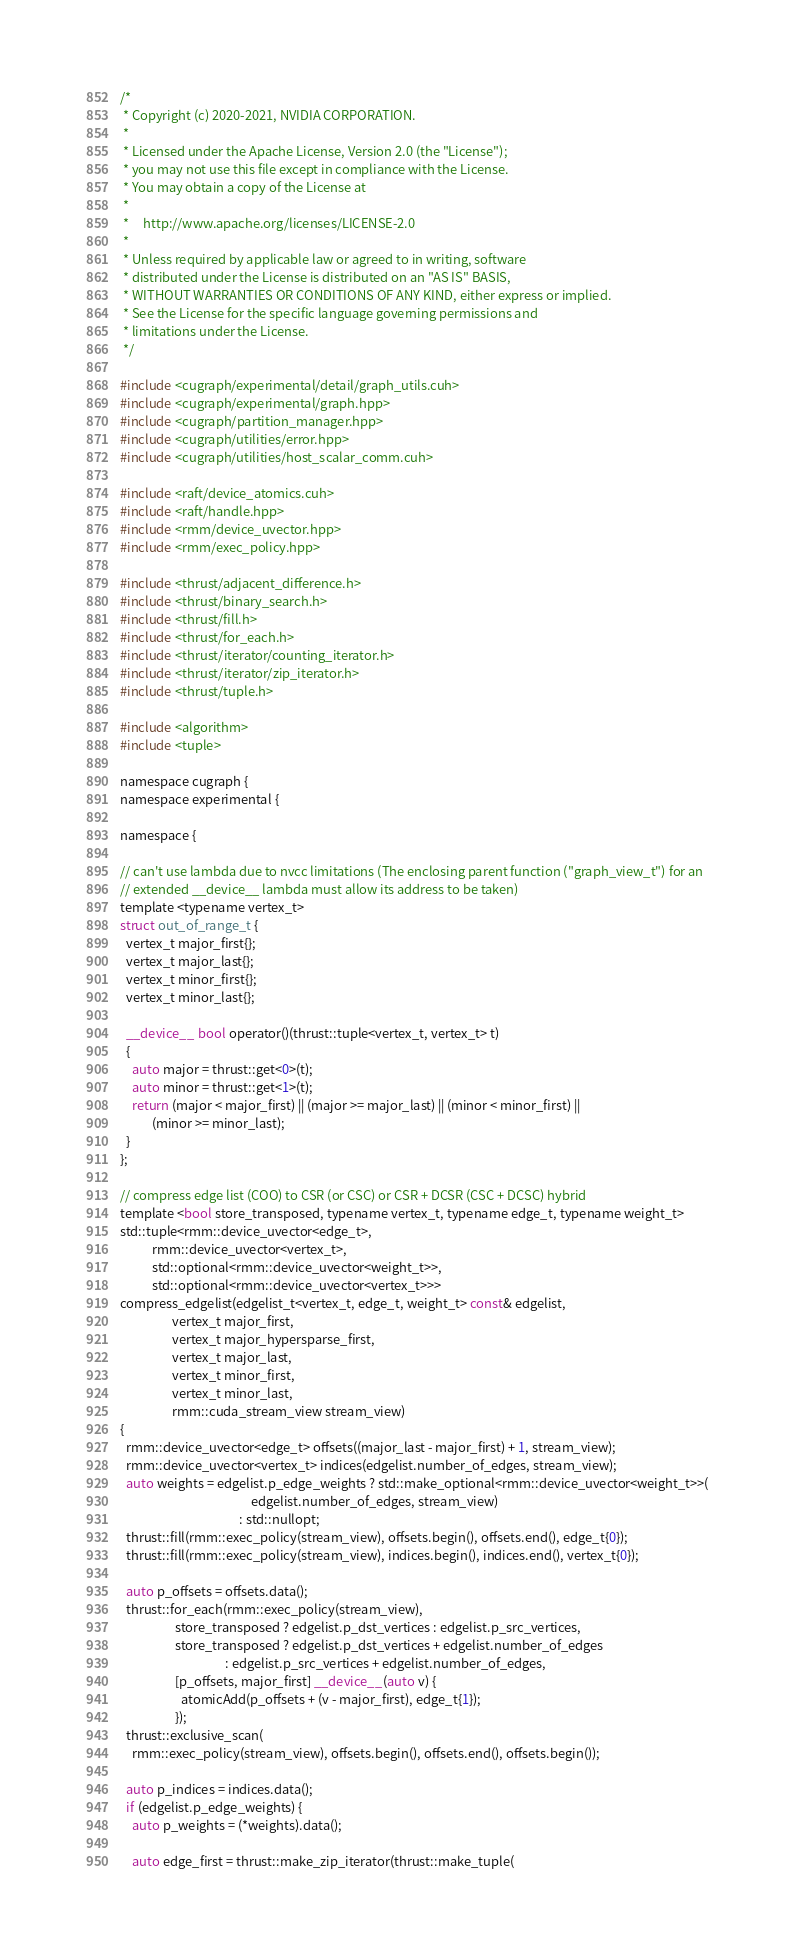<code> <loc_0><loc_0><loc_500><loc_500><_Cuda_>/*
 * Copyright (c) 2020-2021, NVIDIA CORPORATION.
 *
 * Licensed under the Apache License, Version 2.0 (the "License");
 * you may not use this file except in compliance with the License.
 * You may obtain a copy of the License at
 *
 *     http://www.apache.org/licenses/LICENSE-2.0
 *
 * Unless required by applicable law or agreed to in writing, software
 * distributed under the License is distributed on an "AS IS" BASIS,
 * WITHOUT WARRANTIES OR CONDITIONS OF ANY KIND, either express or implied.
 * See the License for the specific language governing permissions and
 * limitations under the License.
 */

#include <cugraph/experimental/detail/graph_utils.cuh>
#include <cugraph/experimental/graph.hpp>
#include <cugraph/partition_manager.hpp>
#include <cugraph/utilities/error.hpp>
#include <cugraph/utilities/host_scalar_comm.cuh>

#include <raft/device_atomics.cuh>
#include <raft/handle.hpp>
#include <rmm/device_uvector.hpp>
#include <rmm/exec_policy.hpp>

#include <thrust/adjacent_difference.h>
#include <thrust/binary_search.h>
#include <thrust/fill.h>
#include <thrust/for_each.h>
#include <thrust/iterator/counting_iterator.h>
#include <thrust/iterator/zip_iterator.h>
#include <thrust/tuple.h>

#include <algorithm>
#include <tuple>

namespace cugraph {
namespace experimental {

namespace {

// can't use lambda due to nvcc limitations (The enclosing parent function ("graph_view_t") for an
// extended __device__ lambda must allow its address to be taken)
template <typename vertex_t>
struct out_of_range_t {
  vertex_t major_first{};
  vertex_t major_last{};
  vertex_t minor_first{};
  vertex_t minor_last{};

  __device__ bool operator()(thrust::tuple<vertex_t, vertex_t> t)
  {
    auto major = thrust::get<0>(t);
    auto minor = thrust::get<1>(t);
    return (major < major_first) || (major >= major_last) || (minor < minor_first) ||
           (minor >= minor_last);
  }
};

// compress edge list (COO) to CSR (or CSC) or CSR + DCSR (CSC + DCSC) hybrid
template <bool store_transposed, typename vertex_t, typename edge_t, typename weight_t>
std::tuple<rmm::device_uvector<edge_t>,
           rmm::device_uvector<vertex_t>,
           std::optional<rmm::device_uvector<weight_t>>,
           std::optional<rmm::device_uvector<vertex_t>>>
compress_edgelist(edgelist_t<vertex_t, edge_t, weight_t> const& edgelist,
                  vertex_t major_first,
                  vertex_t major_hypersparse_first,
                  vertex_t major_last,
                  vertex_t minor_first,
                  vertex_t minor_last,
                  rmm::cuda_stream_view stream_view)
{
  rmm::device_uvector<edge_t> offsets((major_last - major_first) + 1, stream_view);
  rmm::device_uvector<vertex_t> indices(edgelist.number_of_edges, stream_view);
  auto weights = edgelist.p_edge_weights ? std::make_optional<rmm::device_uvector<weight_t>>(
                                             edgelist.number_of_edges, stream_view)
                                         : std::nullopt;
  thrust::fill(rmm::exec_policy(stream_view), offsets.begin(), offsets.end(), edge_t{0});
  thrust::fill(rmm::exec_policy(stream_view), indices.begin(), indices.end(), vertex_t{0});

  auto p_offsets = offsets.data();
  thrust::for_each(rmm::exec_policy(stream_view),
                   store_transposed ? edgelist.p_dst_vertices : edgelist.p_src_vertices,
                   store_transposed ? edgelist.p_dst_vertices + edgelist.number_of_edges
                                    : edgelist.p_src_vertices + edgelist.number_of_edges,
                   [p_offsets, major_first] __device__(auto v) {
                     atomicAdd(p_offsets + (v - major_first), edge_t{1});
                   });
  thrust::exclusive_scan(
    rmm::exec_policy(stream_view), offsets.begin(), offsets.end(), offsets.begin());

  auto p_indices = indices.data();
  if (edgelist.p_edge_weights) {
    auto p_weights = (*weights).data();

    auto edge_first = thrust::make_zip_iterator(thrust::make_tuple(</code> 